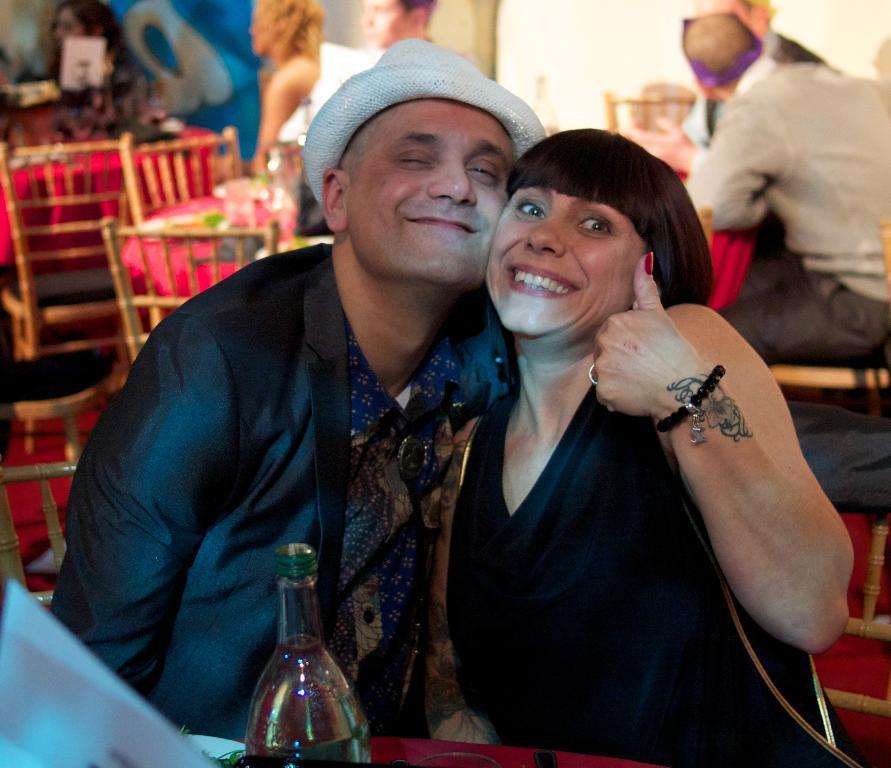Can you describe this image briefly? This man and this woman are highlighted in this picture. This man wore black suit and cap. This woman wore black dress. In-front of this person there is a table, on a table there is a bottle. We can able to see number of chairs and tables. These persons are sitting on a chair. 